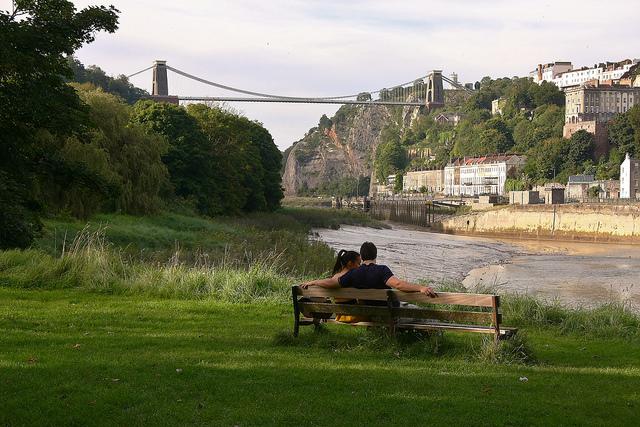How many people are standing up?
Answer briefly. 0. What kind of bridge is in the back?
Be succinct. Suspension bridge. Is there water in this picture?
Give a very brief answer. Yes. 